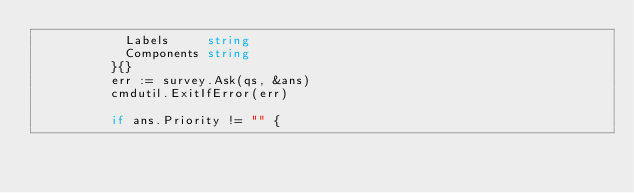Convert code to text. <code><loc_0><loc_0><loc_500><loc_500><_Go_>						Labels     string
						Components string
					}{}
					err := survey.Ask(qs, &ans)
					cmdutil.ExitIfError(err)

					if ans.Priority != "" {</code> 